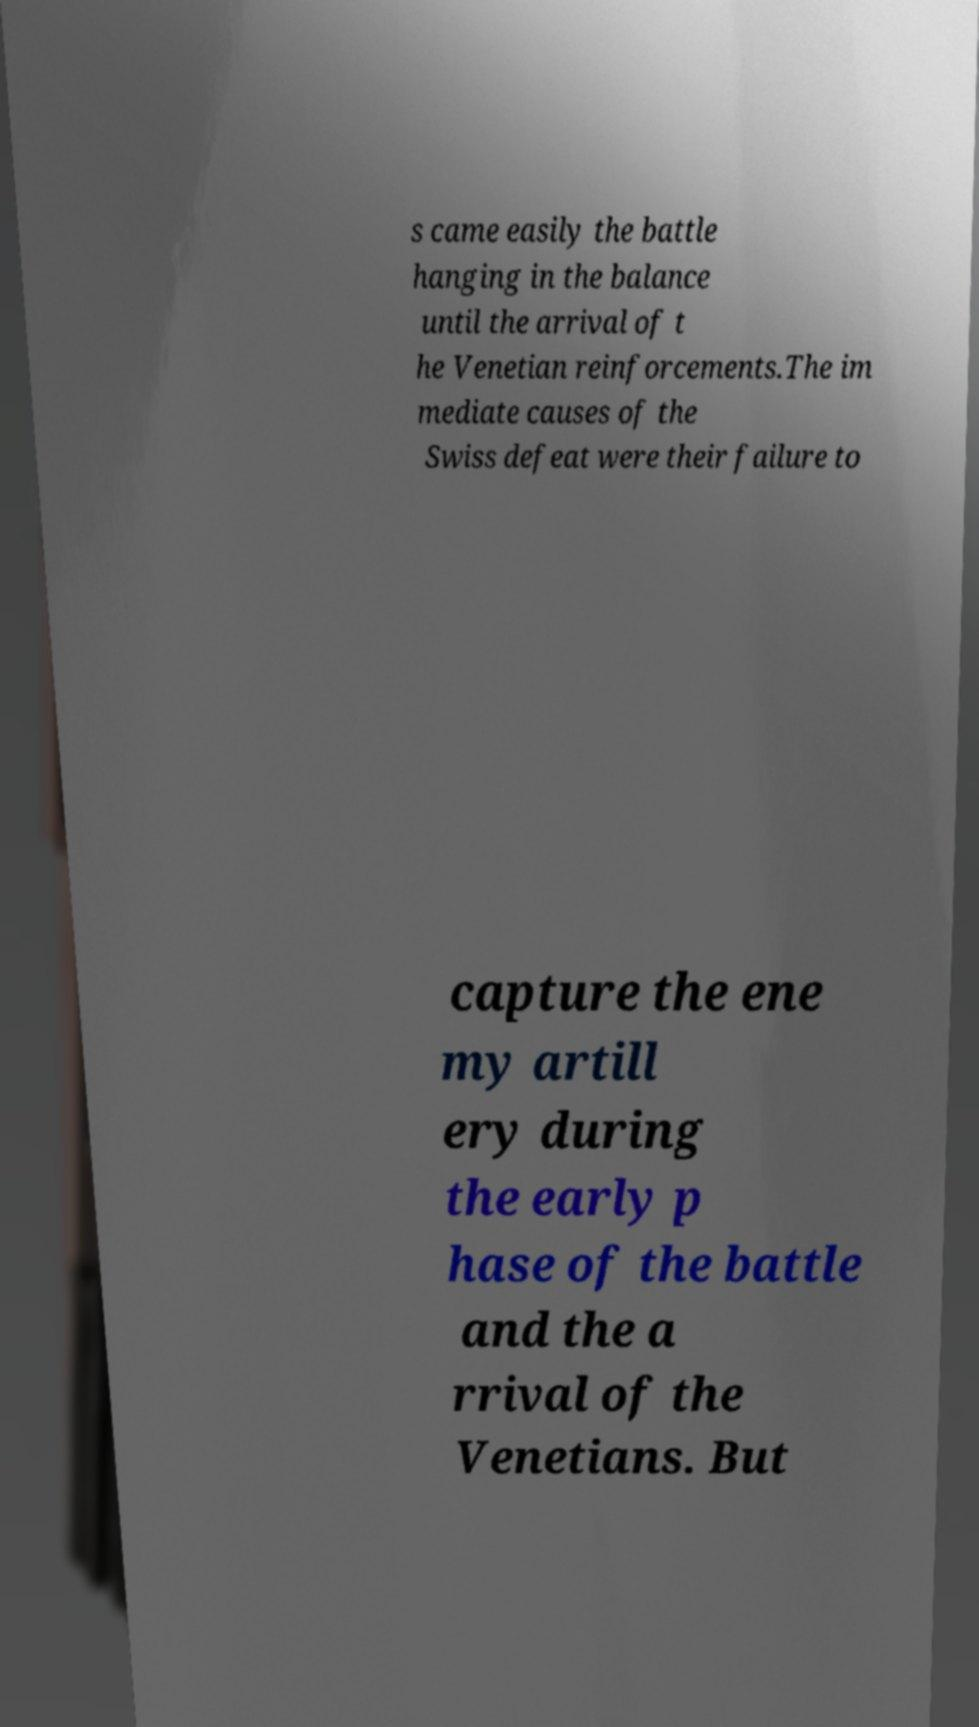There's text embedded in this image that I need extracted. Can you transcribe it verbatim? s came easily the battle hanging in the balance until the arrival of t he Venetian reinforcements.The im mediate causes of the Swiss defeat were their failure to capture the ene my artill ery during the early p hase of the battle and the a rrival of the Venetians. But 